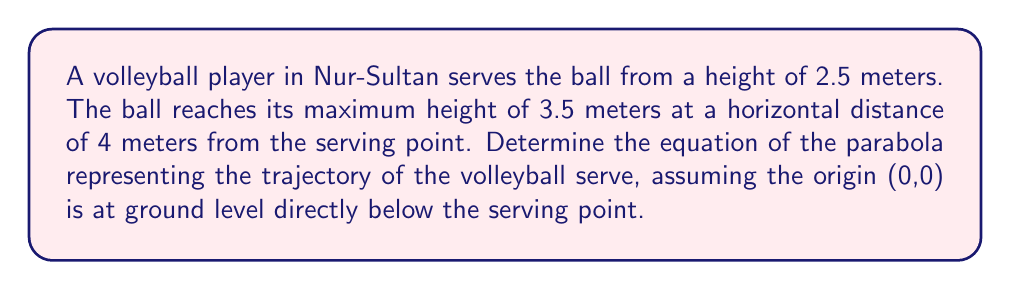Solve this math problem. Let's approach this step-by-step:

1) The general equation of a parabola is $y = ax^2 + bx + c$, where $a$, $b$, and $c$ are constants we need to determine.

2) We know three points on this parabola:
   - The starting point: (0, 2.5)
   - The vertex: (4, 3.5)
   - Another point: (8, 2.5) (symmetric to the starting point)

3) Using the vertex form of a parabola: $y = a(x-h)^2 + k$, where (h,k) is the vertex.
   So, our equation will be of the form: $y = a(x-4)^2 + 3.5$

4) Now we can use the starting point (0, 2.5) to find $a$:
   $2.5 = a(0-4)^2 + 3.5$
   $2.5 = 16a + 3.5$
   $-1 = 16a$
   $a = -\frac{1}{16} = -0.0625$

5) Therefore, the equation of the parabola is:
   $y = -0.0625(x-4)^2 + 3.5$

6) Expanding this:
   $y = -0.0625(x^2 - 8x + 16) + 3.5$
   $y = -0.0625x^2 + 0.5x - 1 + 3.5$
   $y = -0.0625x^2 + 0.5x + 2.5$

This is the equation of the parabola representing the trajectory of the volleyball serve.
Answer: $y = -0.0625x^2 + 0.5x + 2.5$ 